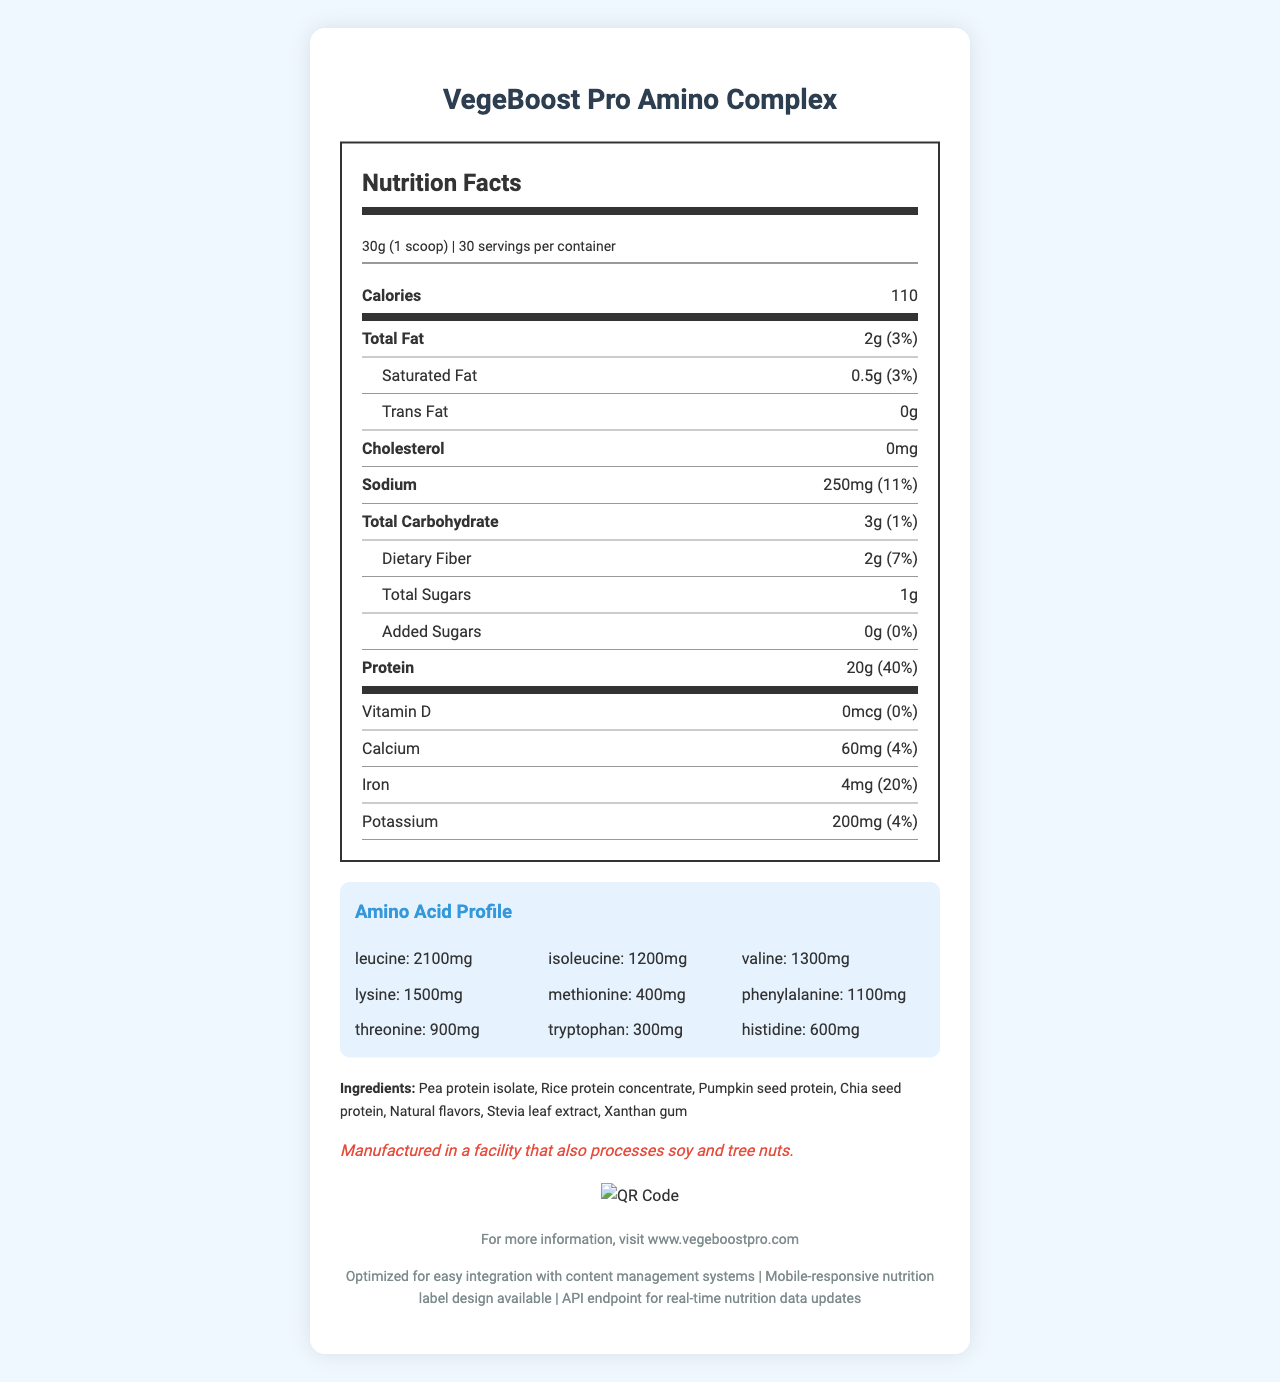what is the serving size of VegeBoost Pro Amino Complex? According to the nutrition label, the serving size is listed as 30g (1 scoop).
Answer: 30g (1 scoop) how many calories are in one serving? The nutrition label indicates that one serving contains 110 calories.
Answer: 110 calories how much total fat does one serving contain? The document states that one serving of VegeBoost Pro Amino Complex contains 2g of total fat.
Answer: 2g how many grams of protein are in each serving? Each serving contains 20g of protein as stated in the nutrition facts.
Answer: 20g what types of protein are included in the ingredients? The ingredients list includes Pea protein isolate, Rice protein concentrate, Pumpkin seed protein, and Chia seed protein.
Answer: Pea protein isolate, Rice protein concentrate, Pumpkin seed protein, Chia seed protein which amino acid has the highest amount in the amino acid profile? A. Leucine B. Isoleucine C. Lysine The amino acid profile lists Leucine with 2100mg, which is the highest amount among the amino acids shown.
Answer: A. Leucine what is the daily value percentage of iron in one serving? The nutrition label states that each serving has a daily value percentage of 20% for iron.
Answer: 20% which ingredient is used as a sweetener? A. Stevia leaf extract B. Xanthan gum C. Natural flavors Stevia leaf extract is commonly used as a sweetener and it is listed as an ingredient.
Answer: A. Stevia leaf extract is there any cholesterol in VegeBoost Pro Amino Complex? The document clearly states that there is 0mg of cholesterol.
Answer: No summarize the main point of the document. The document is a complete summary of the nutritional information for the VegeBoost Pro Amino Complex protein powder, highlighting the key nutritional components and detailed amino acid profile along with the ingredients and other relevant product information.
Answer: The document provides the nutrition facts for VegeBoost Pro Amino Complex, a plant-based protein powder with details about serving size, number of servings, nutritional content (calories, fats, sodium, carbohydrates, protein, vitamins and minerals), amino acid profile, ingredients, allergen information, and additional product notes. how many servings are there per container of VegeBoost Pro Amino Complex? The document specifies that there are 30 servings per container.
Answer: 30 is the product allergen-free? The allergen information states that the product is manufactured in a facility that also processes soy and tree nuts.
Answer: No what is the website for more information? The document provides a website URL for more information: www.vegeboostpro.com.
Answer: www.vegeboostpro.com how much leucine is in a serving? The amino acid profile lists 2100mg of leucine per serving.
Answer: 2100mg how much methionine is in a serving? The amino acid profile lists 400mg of methionine per serving.
Answer: 400mg what is the daily value percentage of sodium in one serving? A. 3% B. 7% C. 11% D. 20% The document states that one serving has an 11% daily value for sodium.
Answer: C. 11% how much vitamin D is in a serving? The document states there is 0mcg of vitamin D in each serving.
Answer: 0mcg what is the QR code URL provided in the document? A. www.vegeboostpro.com B. https://vegeboostpro.com/amino-complex-facts C. www.vegeboost-amino.com The QR code provided in the document directs to https://vegeboostpro.com/amino-complex-facts.
Answer: B. https://vegeboostpro.com/amino-complex-facts is this document optimized for integration with content management systems? The document’s custom notes mention that it is optimized for easy integration with content management systems.
Answer: Yes where is the product manufactured? The document does not provide information about the manufacturing location, only that it is processed in a facility that handles soy and tree nuts.
Answer: Not enough information 